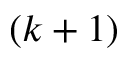<formula> <loc_0><loc_0><loc_500><loc_500>( k + 1 )</formula> 